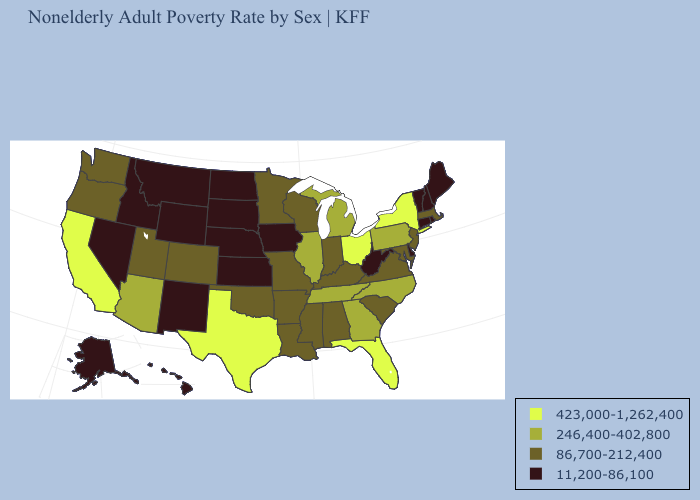Name the states that have a value in the range 86,700-212,400?
Short answer required. Alabama, Arkansas, Colorado, Indiana, Kentucky, Louisiana, Maryland, Massachusetts, Minnesota, Mississippi, Missouri, New Jersey, Oklahoma, Oregon, South Carolina, Utah, Virginia, Washington, Wisconsin. Among the states that border Indiana , which have the lowest value?
Keep it brief. Kentucky. What is the value of Mississippi?
Short answer required. 86,700-212,400. Does Michigan have the same value as Wisconsin?
Keep it brief. No. Among the states that border Tennessee , does Mississippi have the highest value?
Concise answer only. No. Does Alabama have the same value as Kentucky?
Answer briefly. Yes. What is the value of Kentucky?
Keep it brief. 86,700-212,400. Does the first symbol in the legend represent the smallest category?
Give a very brief answer. No. Name the states that have a value in the range 86,700-212,400?
Be succinct. Alabama, Arkansas, Colorado, Indiana, Kentucky, Louisiana, Maryland, Massachusetts, Minnesota, Mississippi, Missouri, New Jersey, Oklahoma, Oregon, South Carolina, Utah, Virginia, Washington, Wisconsin. What is the lowest value in the USA?
Write a very short answer. 11,200-86,100. Which states have the highest value in the USA?
Keep it brief. California, Florida, New York, Ohio, Texas. Which states have the lowest value in the West?
Be succinct. Alaska, Hawaii, Idaho, Montana, Nevada, New Mexico, Wyoming. What is the value of South Carolina?
Keep it brief. 86,700-212,400. Name the states that have a value in the range 86,700-212,400?
Give a very brief answer. Alabama, Arkansas, Colorado, Indiana, Kentucky, Louisiana, Maryland, Massachusetts, Minnesota, Mississippi, Missouri, New Jersey, Oklahoma, Oregon, South Carolina, Utah, Virginia, Washington, Wisconsin. What is the value of West Virginia?
Be succinct. 11,200-86,100. 